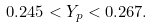<formula> <loc_0><loc_0><loc_500><loc_500>0 . 2 4 5 < Y _ { p } < 0 . 2 6 7 .</formula> 